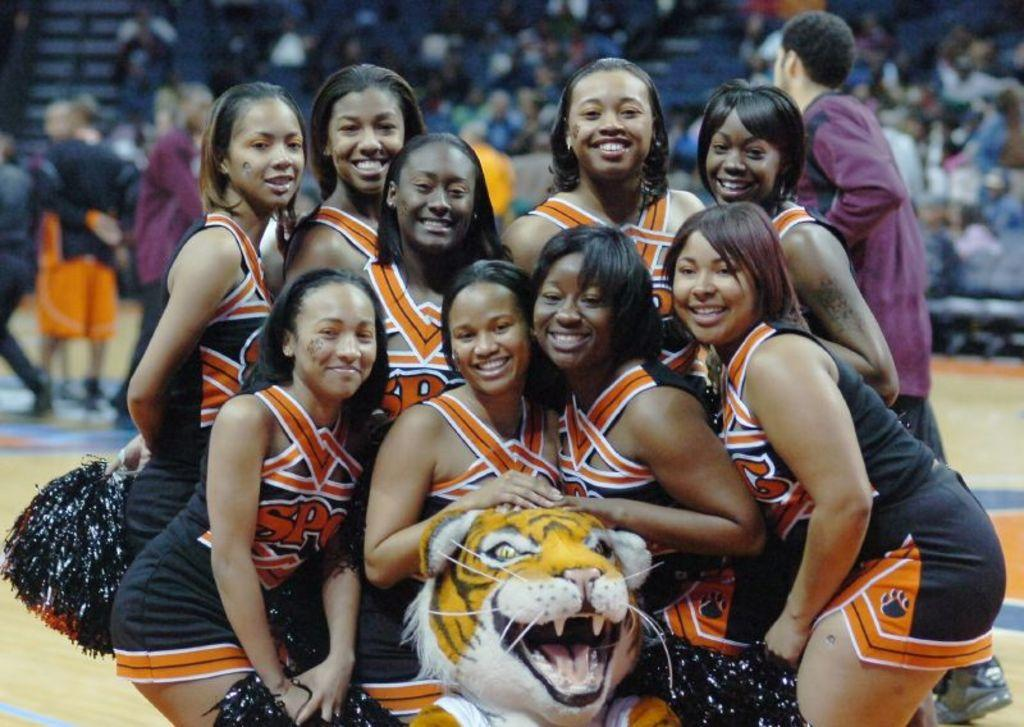Who is present in the image? There are girls in the image. What is the facial expression of the girls? The girls are smiling. What are the people behind the girls doing? The people behind the girls are standing and walking. What can be seen beneath the girls in the image? The ground is visible in the image. What type of audience can be seen in the background? There are spectators in the background of the image. What type of flesh can be seen on the girls in the image? There is no mention of flesh in the image, and it is not appropriate to discuss body parts in this context. 